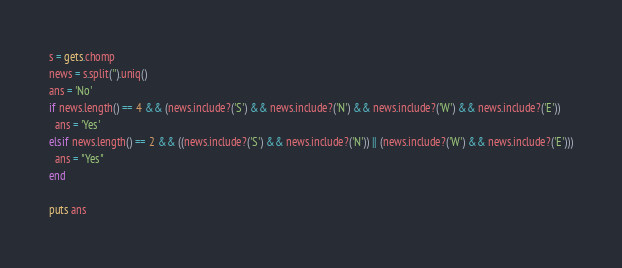Convert code to text. <code><loc_0><loc_0><loc_500><loc_500><_Ruby_>s = gets.chomp
news = s.split('').uniq()
ans = 'No'
if news.length() == 4 && (news.include?('S') && news.include?('N') && news.include?('W') && news.include?('E'))
  ans = 'Yes'
elsif news.length() == 2 && ((news.include?('S') && news.include?('N')) || (news.include?('W') && news.include?('E')))
  ans = "Yes"
end

puts ans</code> 